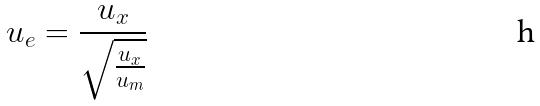Convert formula to latex. <formula><loc_0><loc_0><loc_500><loc_500>u _ { e } = \frac { u _ { x } } { \sqrt { \frac { u _ { x } } { u _ { m } } } }</formula> 